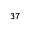<formula> <loc_0><loc_0><loc_500><loc_500>^ { 3 7 }</formula> 